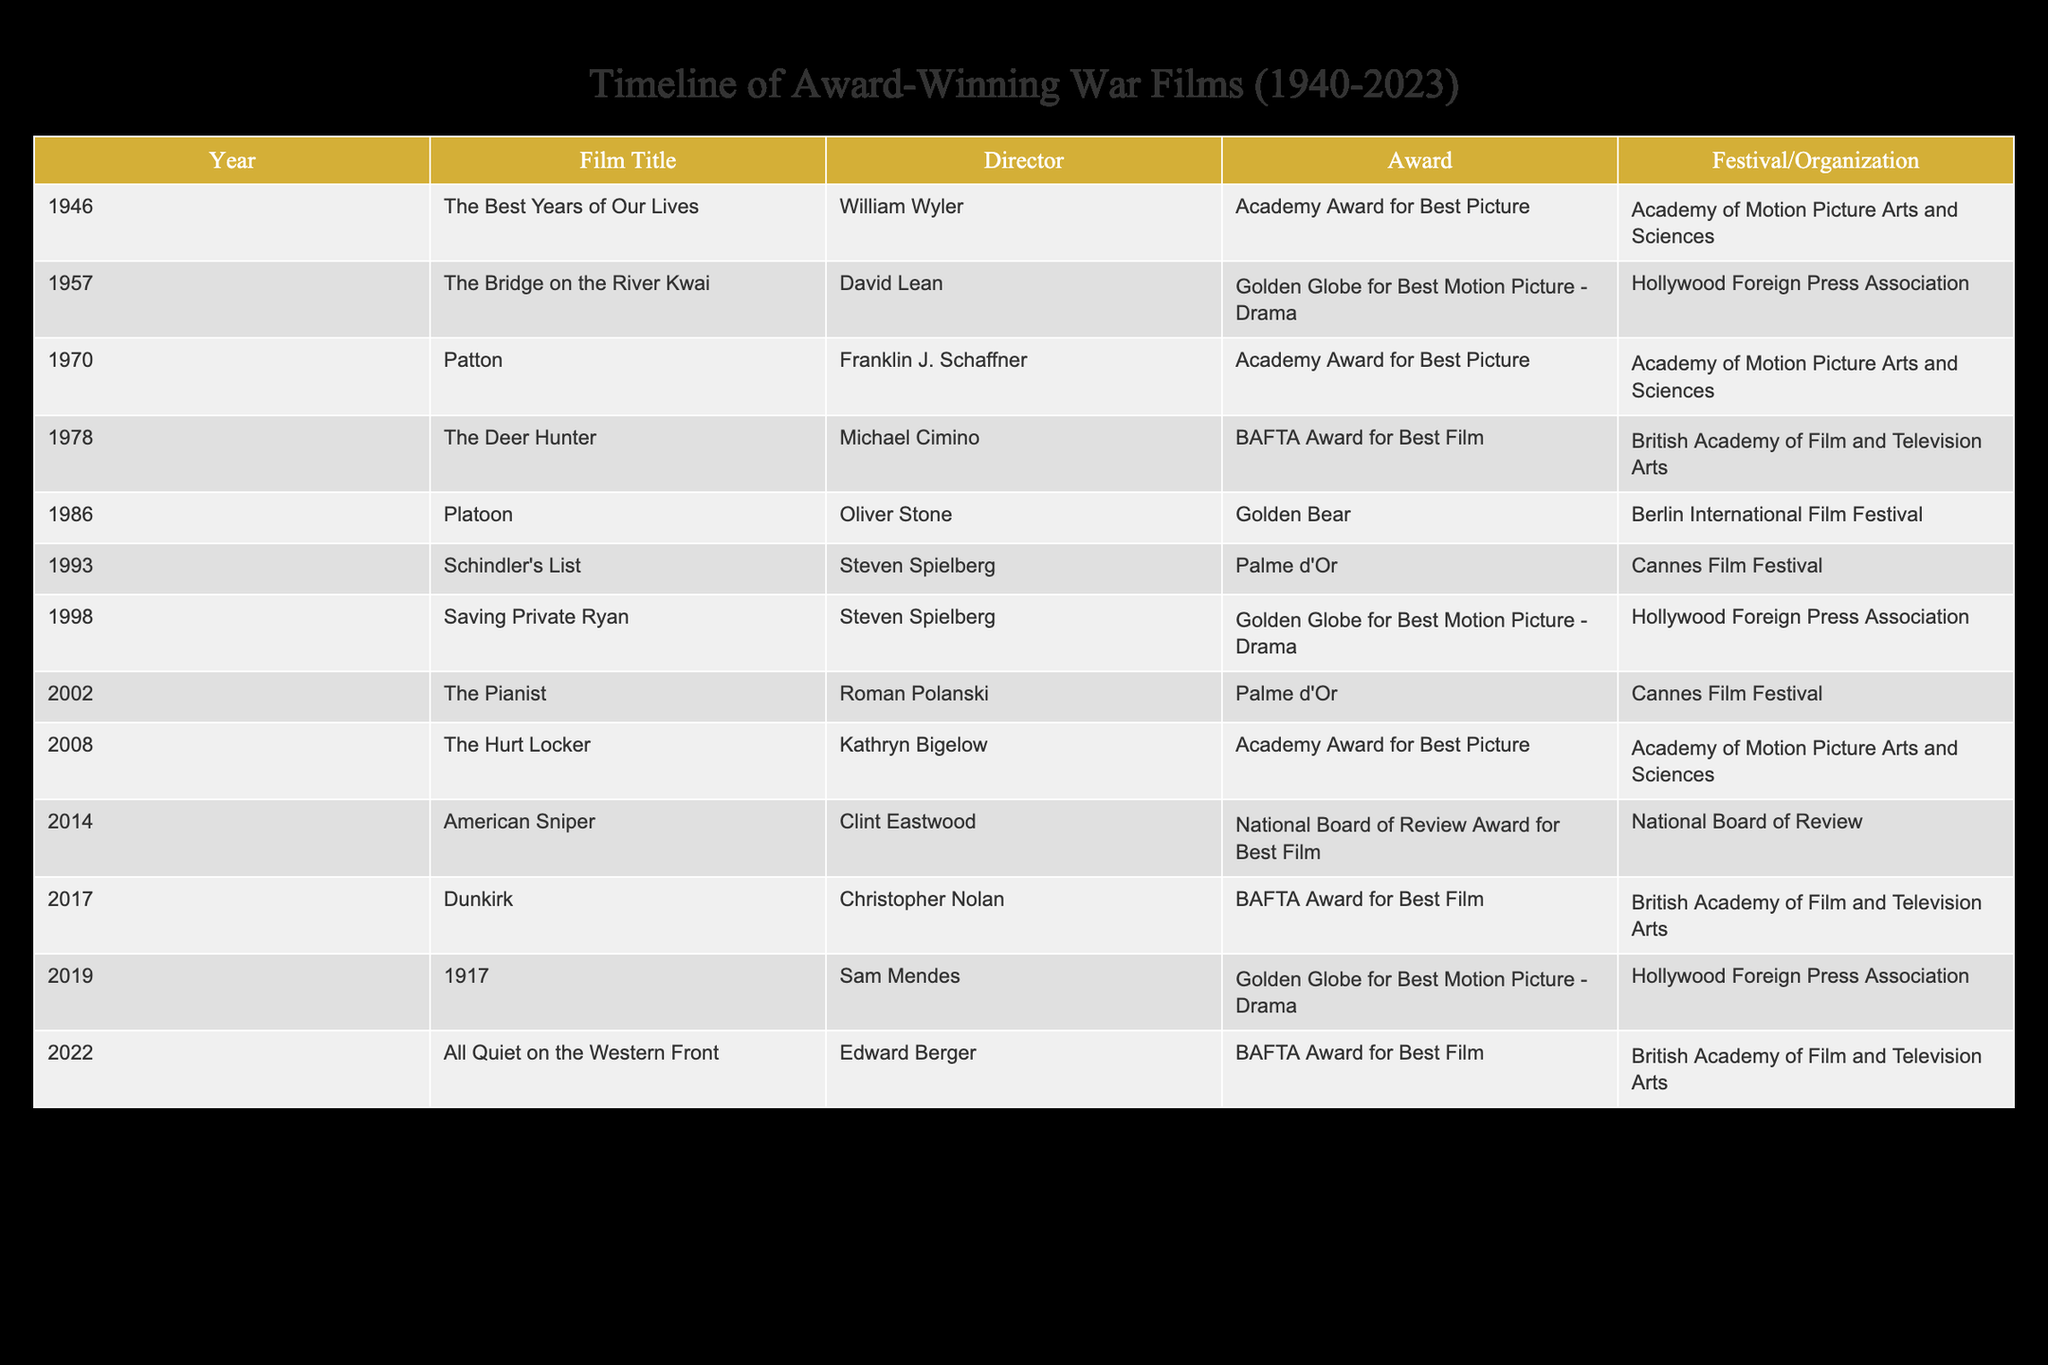What is the title of the film directed by Steven Spielberg that won the Academy Award for Best Picture? The table lists films along with their directors and awards. Searching for the entry with director "Steven Spielberg" and matching it with the award "Academy Award for Best Picture," I found that "Schindler's List" does not fit this requirement, as it won the Palme d'Or. Therefore, there is no film by Spielberg with this specific award in the table.
Answer: None Which film won the Golden Bear at the Berlin International Film Festival? According to the table, the only film that lists "Golden Bear" as the award and "Berlin International Film Festival" as the organization is "Platoon," directed by Oliver Stone in 1986.
Answer: Platoon How many films won the BAFTA Award for Best Film between 1975 and 2022? Checking the table, the films that won the BAFTA Award for Best Film are "The Deer Hunter" (1978), "The Hurt Locker" (2009), "Dunkirk" (2017), and "All Quiet on the Western Front" (2022). That totals to four films within the specified range.
Answer: 4 Was "Saving Private Ryan" awarded the Palme d'Or at Cannes Film Festival? The table shows that "Saving Private Ryan" won the Golden Globe for Best Motion Picture - Drama, and it does not list the Palme d'Or as an award for this film, so the answer is no.
Answer: No Which film released in 2019 won an award at the Hollywood Foreign Press Association? From the table, the film listed for 2019 is "1917," and it won the Golden Globe for Best Motion Picture - Drama. This confirms that it did indeed win an award from that organization.
Answer: Yes What year saw the release of both "The Best Years of Our Lives" and "The Deer Hunter"? Analyzing the table, "The Best Years of Our Lives" was released in 1946 and "The Deer Hunter" in 1978. These two films do not share the same release year.
Answer: None Which director has the most films listed in this table? Reviewing the table, we see Steven Spielberg has two entries: "Schindler's List" and "Saving Private Ryan." The other directors each have only one entry, making Spielberg the director with the most films in this table.
Answer: Steven Spielberg How many awards are associated with Clint Eastwood's films? The table shows "American Sniper" which won the National Board of Review Award for Best Film. Since there is only one film by Clint Eastwood in the table, the total is one award.
Answer: 1 In what year did "The Hurt Locker" win the Academy Award for Best Picture? According to the table, "The Hurt Locker" directed by Kathryn Bigelow won the Academy Award for Best Picture in 2008.
Answer: 2008 What is the distribution of awards among the films listed? By analyzing the awards, we find that there are several unique awards such as Academy Award for Best Picture, BAFTA Award for Best Film, Golden Globe, and Palme d'Or. While counting each, we find distinct awards like two for Golden Globe, one for National Board of Review, etc. This indicates a diverse distribution of awards among the films listed.
Answer: Diverse 